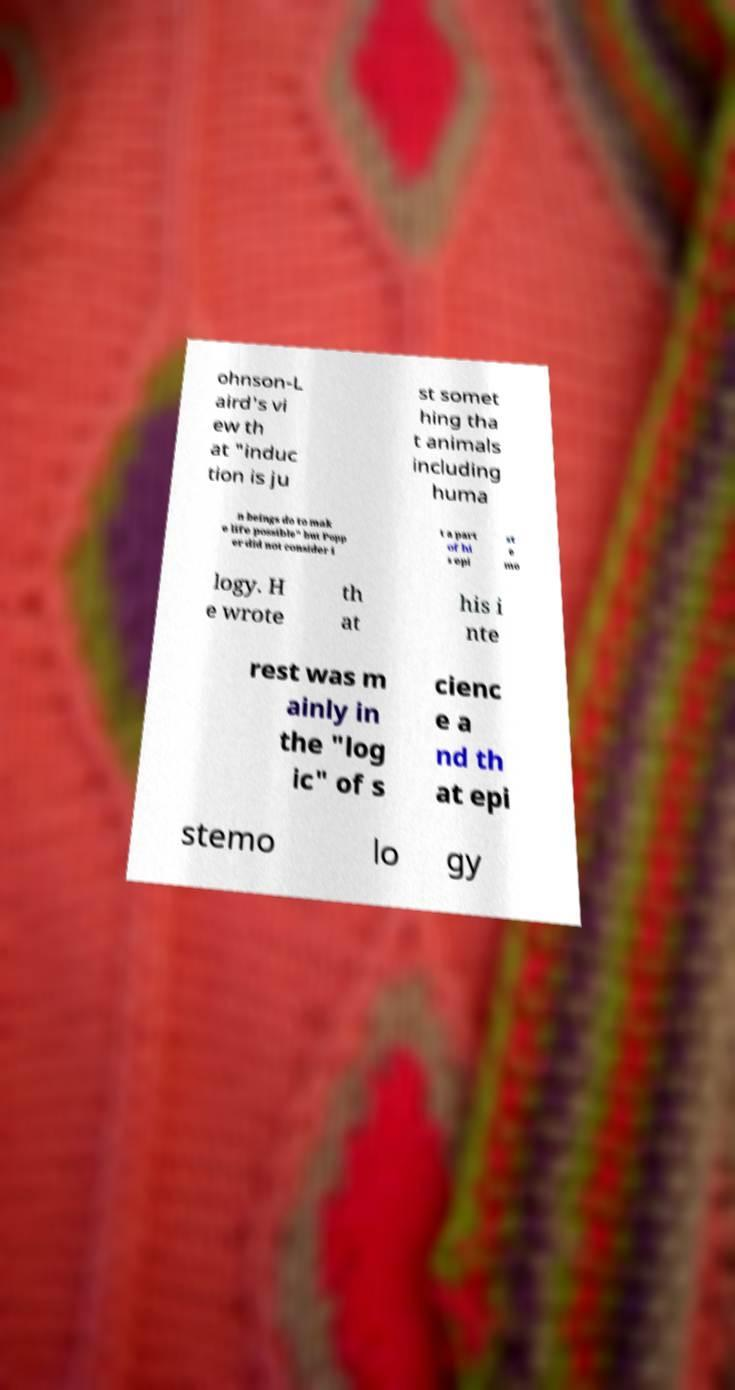Could you assist in decoding the text presented in this image and type it out clearly? ohnson-L aird's vi ew th at "induc tion is ju st somet hing tha t animals including huma n beings do to mak e life possible" but Popp er did not consider i t a part of hi s epi st e mo logy. H e wrote th at his i nte rest was m ainly in the "log ic" of s cienc e a nd th at epi stemo lo gy 